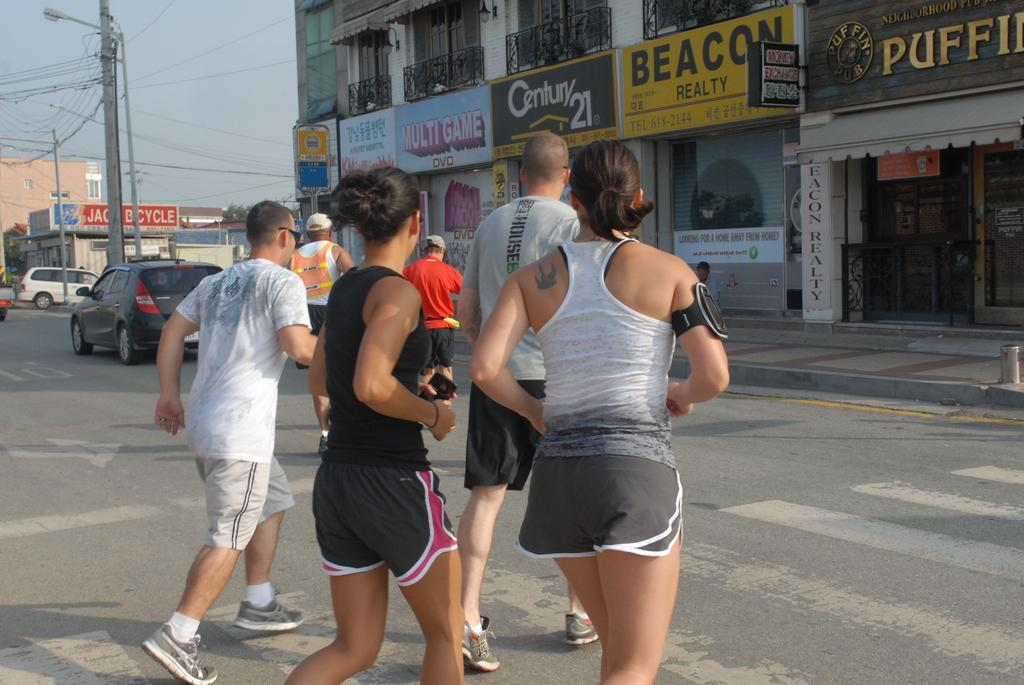<image>
Share a concise interpretation of the image provided. A group of runners going towards a Century 21 building. 